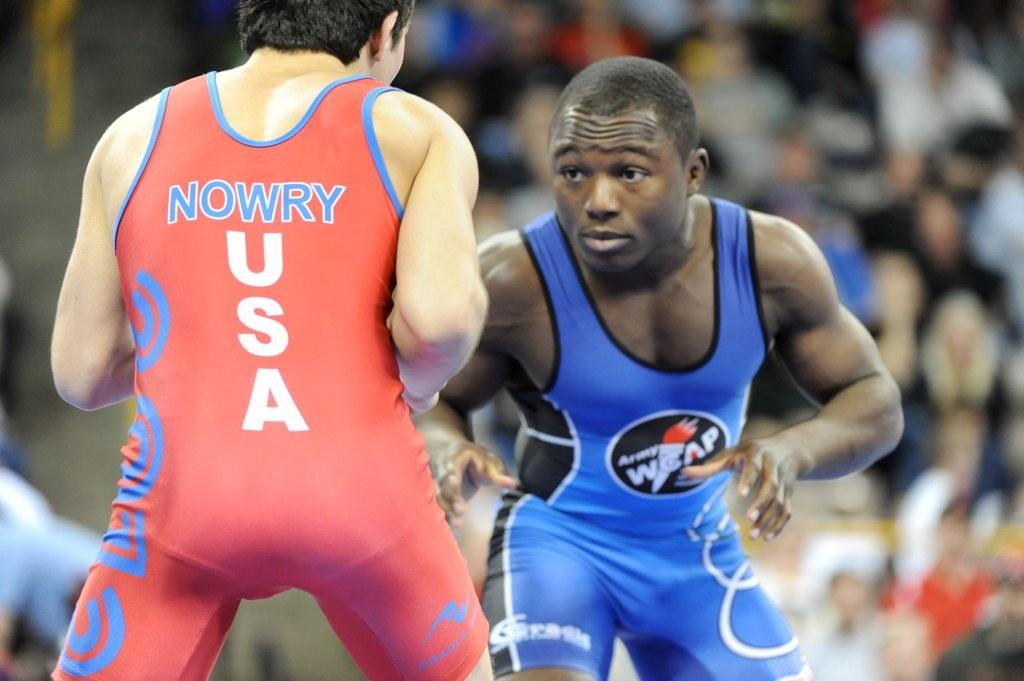<image>
Create a compact narrative representing the image presented. Nowry from the USA prepares to wrestle someone from Army WCAP. 